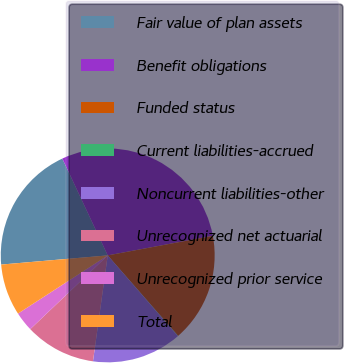Convert chart. <chart><loc_0><loc_0><loc_500><loc_500><pie_chart><fcel>Fair value of plan assets<fcel>Benefit obligations<fcel>Funded status<fcel>Current liabilities-accrued<fcel>Noncurrent liabilities-other<fcel>Unrecognized net actuarial<fcel>Unrecognized prior service<fcel>Total<nl><fcel>19.39%<fcel>29.04%<fcel>16.49%<fcel>0.05%<fcel>13.59%<fcel>10.69%<fcel>2.95%<fcel>7.79%<nl></chart> 